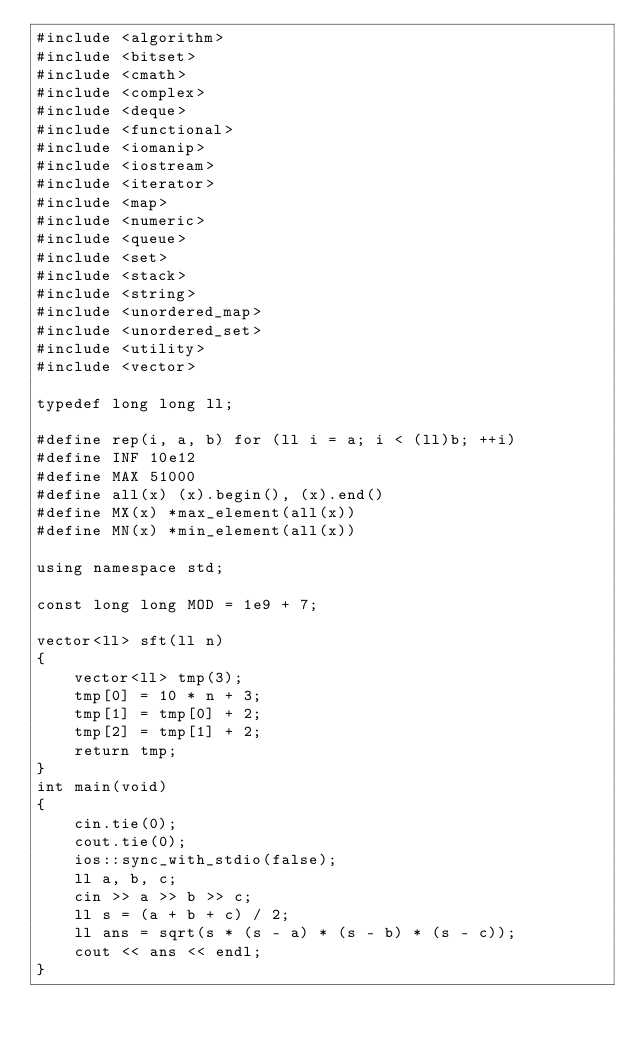<code> <loc_0><loc_0><loc_500><loc_500><_C++_>#include <algorithm>
#include <bitset>
#include <cmath>
#include <complex>
#include <deque>
#include <functional>
#include <iomanip>
#include <iostream>
#include <iterator>
#include <map>
#include <numeric>
#include <queue>
#include <set>
#include <stack>
#include <string>
#include <unordered_map>
#include <unordered_set>
#include <utility>
#include <vector>

typedef long long ll;

#define rep(i, a, b) for (ll i = a; i < (ll)b; ++i)
#define INF 10e12
#define MAX 51000
#define all(x) (x).begin(), (x).end()
#define MX(x) *max_element(all(x))
#define MN(x) *min_element(all(x))

using namespace std;

const long long MOD = 1e9 + 7;

vector<ll> sft(ll n)
{
    vector<ll> tmp(3);
    tmp[0] = 10 * n + 3;
    tmp[1] = tmp[0] + 2;
    tmp[2] = tmp[1] + 2;
    return tmp;
}
int main(void)
{
    cin.tie(0);
    cout.tie(0);
    ios::sync_with_stdio(false);
    ll a, b, c;
    cin >> a >> b >> c;
    ll s = (a + b + c) / 2;
    ll ans = sqrt(s * (s - a) * (s - b) * (s - c));
    cout << ans << endl;
}</code> 